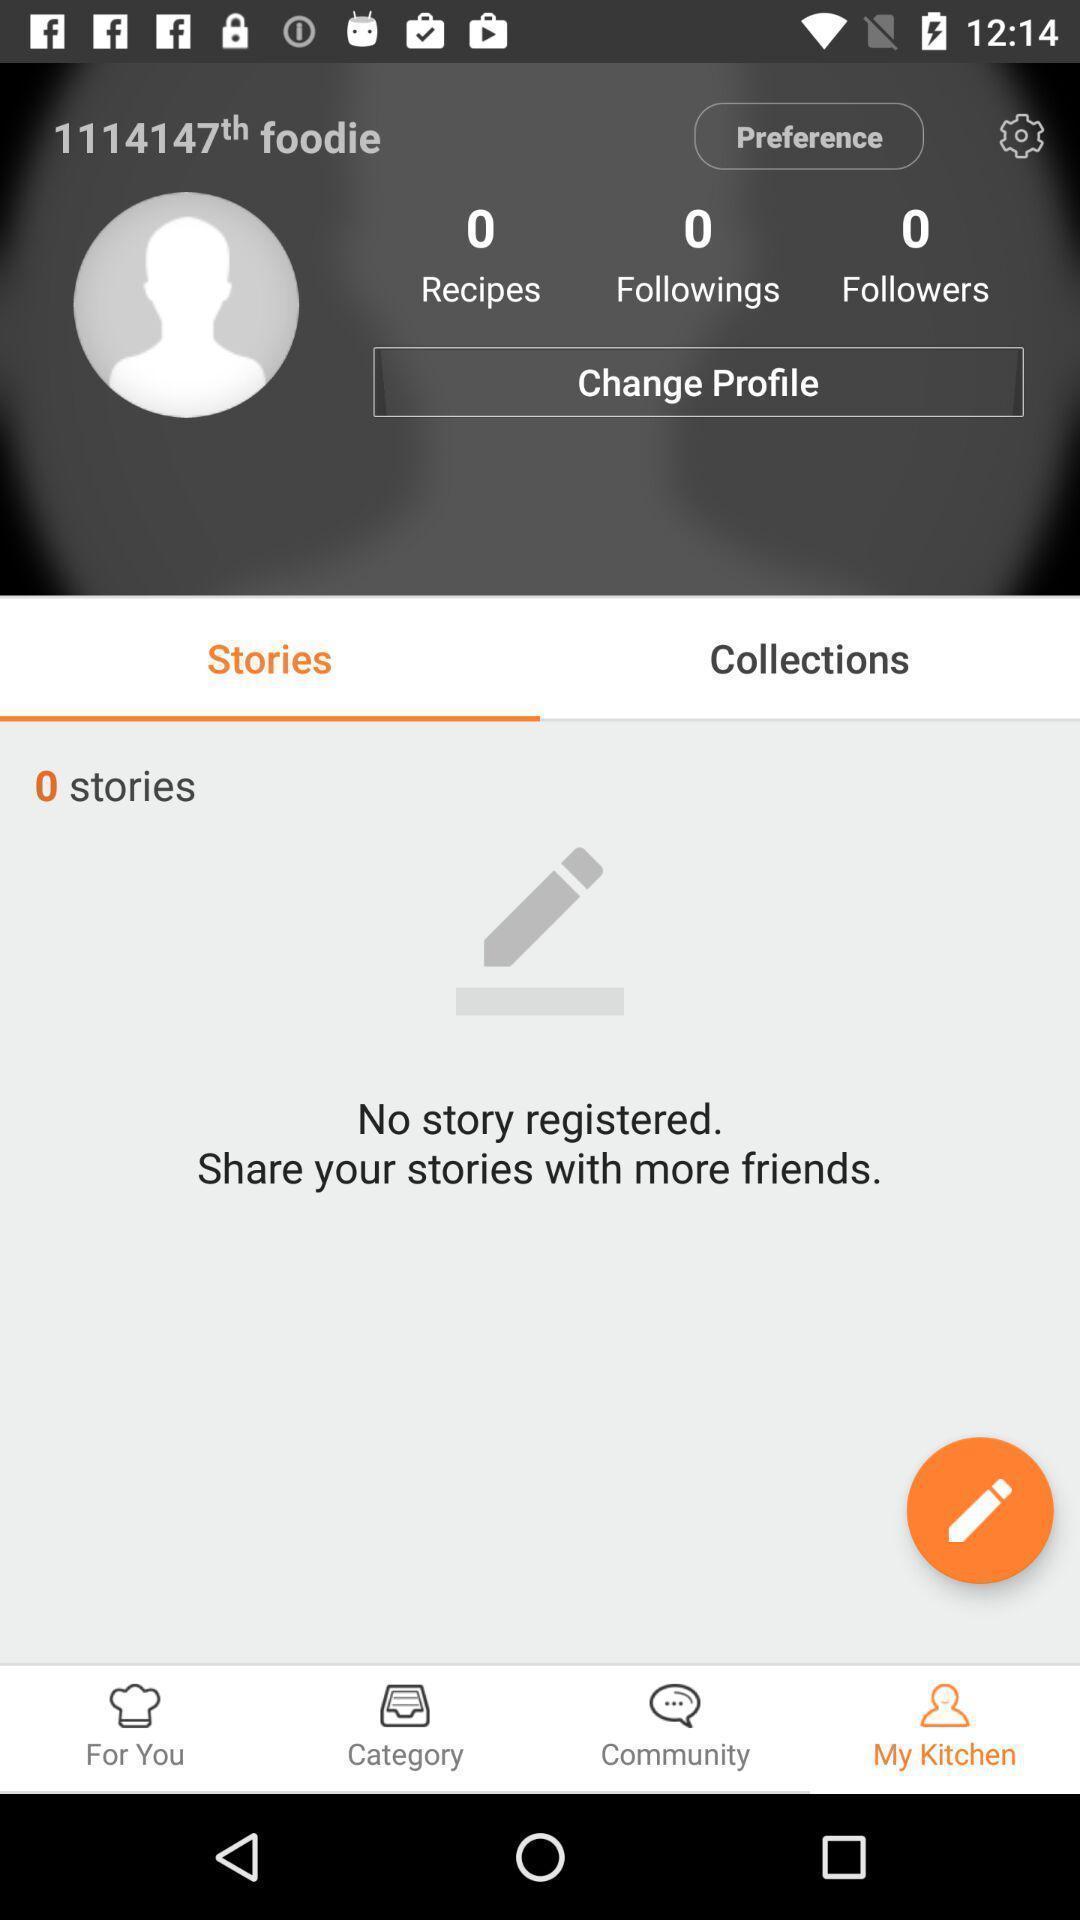What is the overall content of this screenshot? Profile page displaying. 